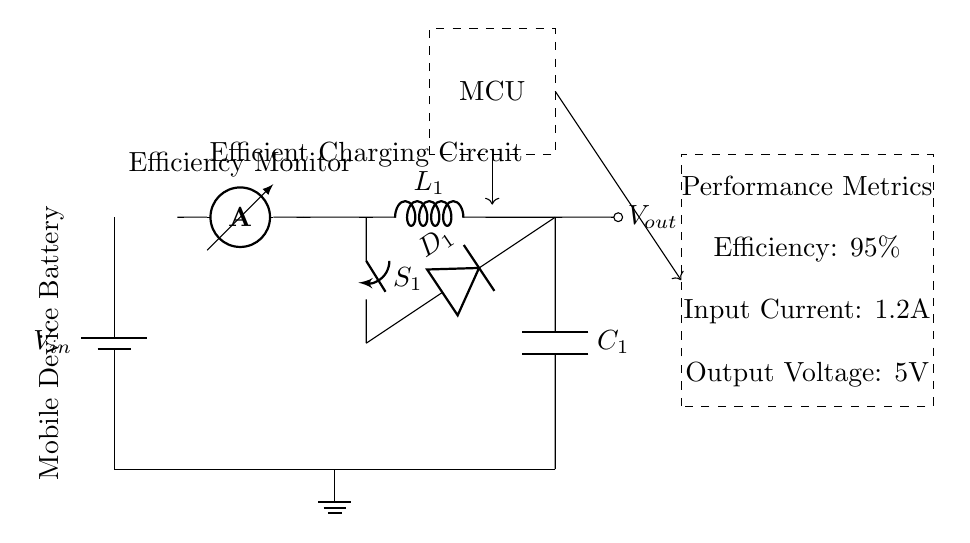What is the input current of the circuit? The input current is 1.2A, which is indicated in the performance metrics display section of the circuit.
Answer: 1.2A What type of converter is used in this charging circuit? The converter is a buck converter, which is noted in the circuit diagram due to the presence of a coil that steps down voltage.
Answer: Buck converter What is the efficiency value of this charging circuit? The efficiency value is 95%, clearly stated in the performance metrics section of the circuit.
Answer: 95% What components are involved in the voltage conversion process? The components involved in voltage conversion include the inductor L1, the switch S1, and the diode D1, which work together to regulate the output voltage from the input.
Answer: L1, S1, D1 What role does the efficiency monitor play in the circuit? The efficiency monitor measures the current flowing through the circuit, helping to evaluate the charging efficiency. This is indicated by the presence of the ammeter component in the diagram.
Answer: Measure current What voltage appears at the output of the circuit? The output voltage is 5V, as indicated in the performance metrics displayed on the right side of the circuit.
Answer: 5V What additional component is shown that measures performance? The additional component is the microcontroller, which is responsible for processing the information gathered from the efficiency monitor to display performance metrics.
Answer: Microcontroller 